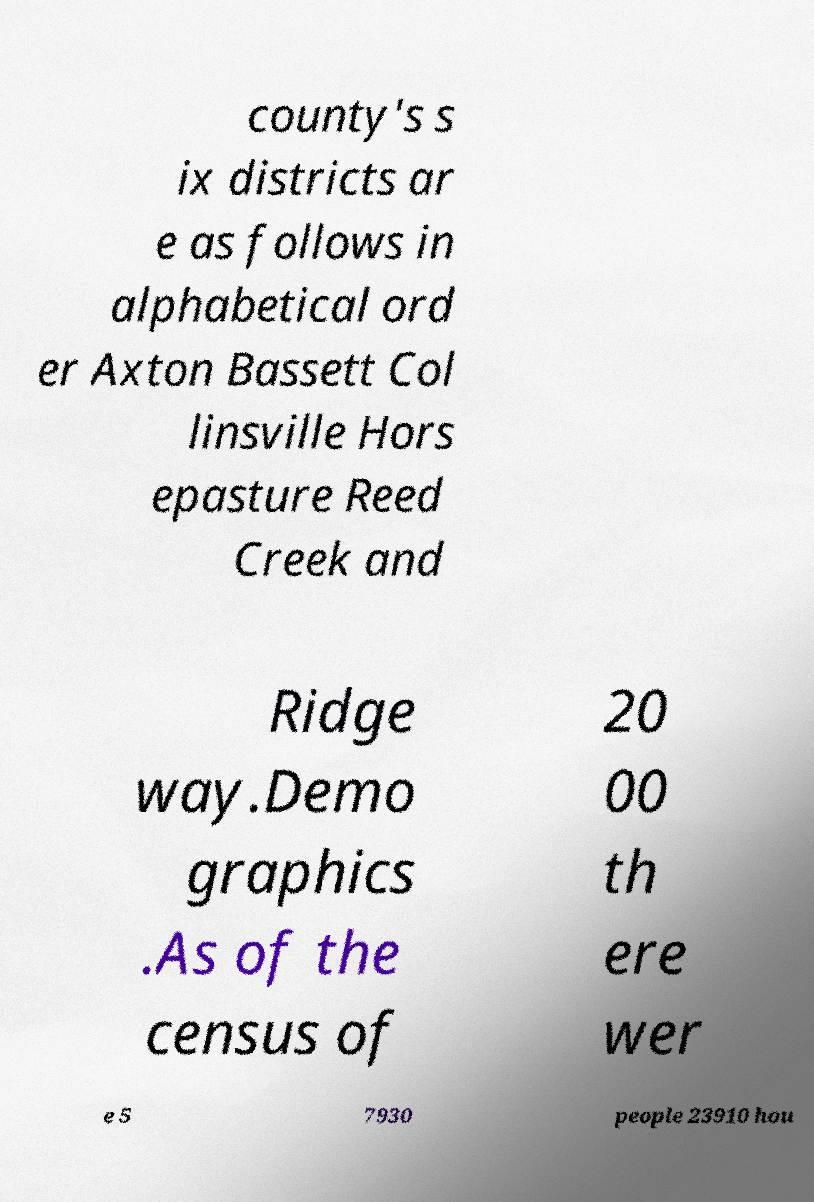What messages or text are displayed in this image? I need them in a readable, typed format. county's s ix districts ar e as follows in alphabetical ord er Axton Bassett Col linsville Hors epasture Reed Creek and Ridge way.Demo graphics .As of the census of 20 00 th ere wer e 5 7930 people 23910 hou 